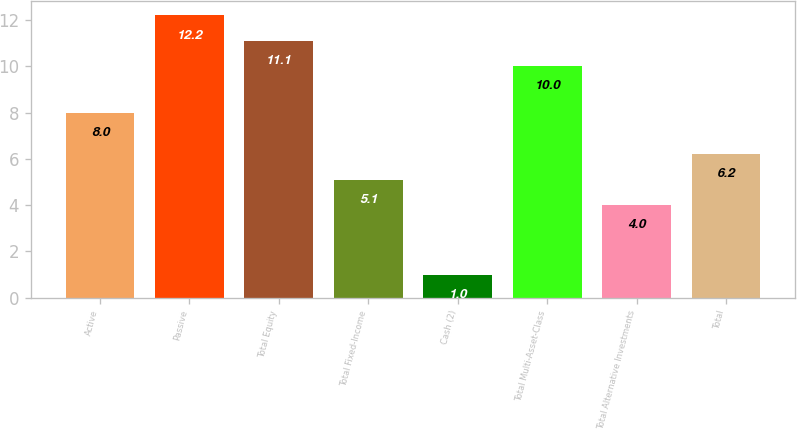<chart> <loc_0><loc_0><loc_500><loc_500><bar_chart><fcel>Active<fcel>Passive<fcel>Total Equity<fcel>Total Fixed-Income<fcel>Cash (2)<fcel>Total Multi-Asset-Class<fcel>Total Alternative Investments<fcel>Total<nl><fcel>8<fcel>12.2<fcel>11.1<fcel>5.1<fcel>1<fcel>10<fcel>4<fcel>6.2<nl></chart> 